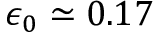Convert formula to latex. <formula><loc_0><loc_0><loc_500><loc_500>\epsilon _ { 0 } \simeq 0 . 1 7</formula> 